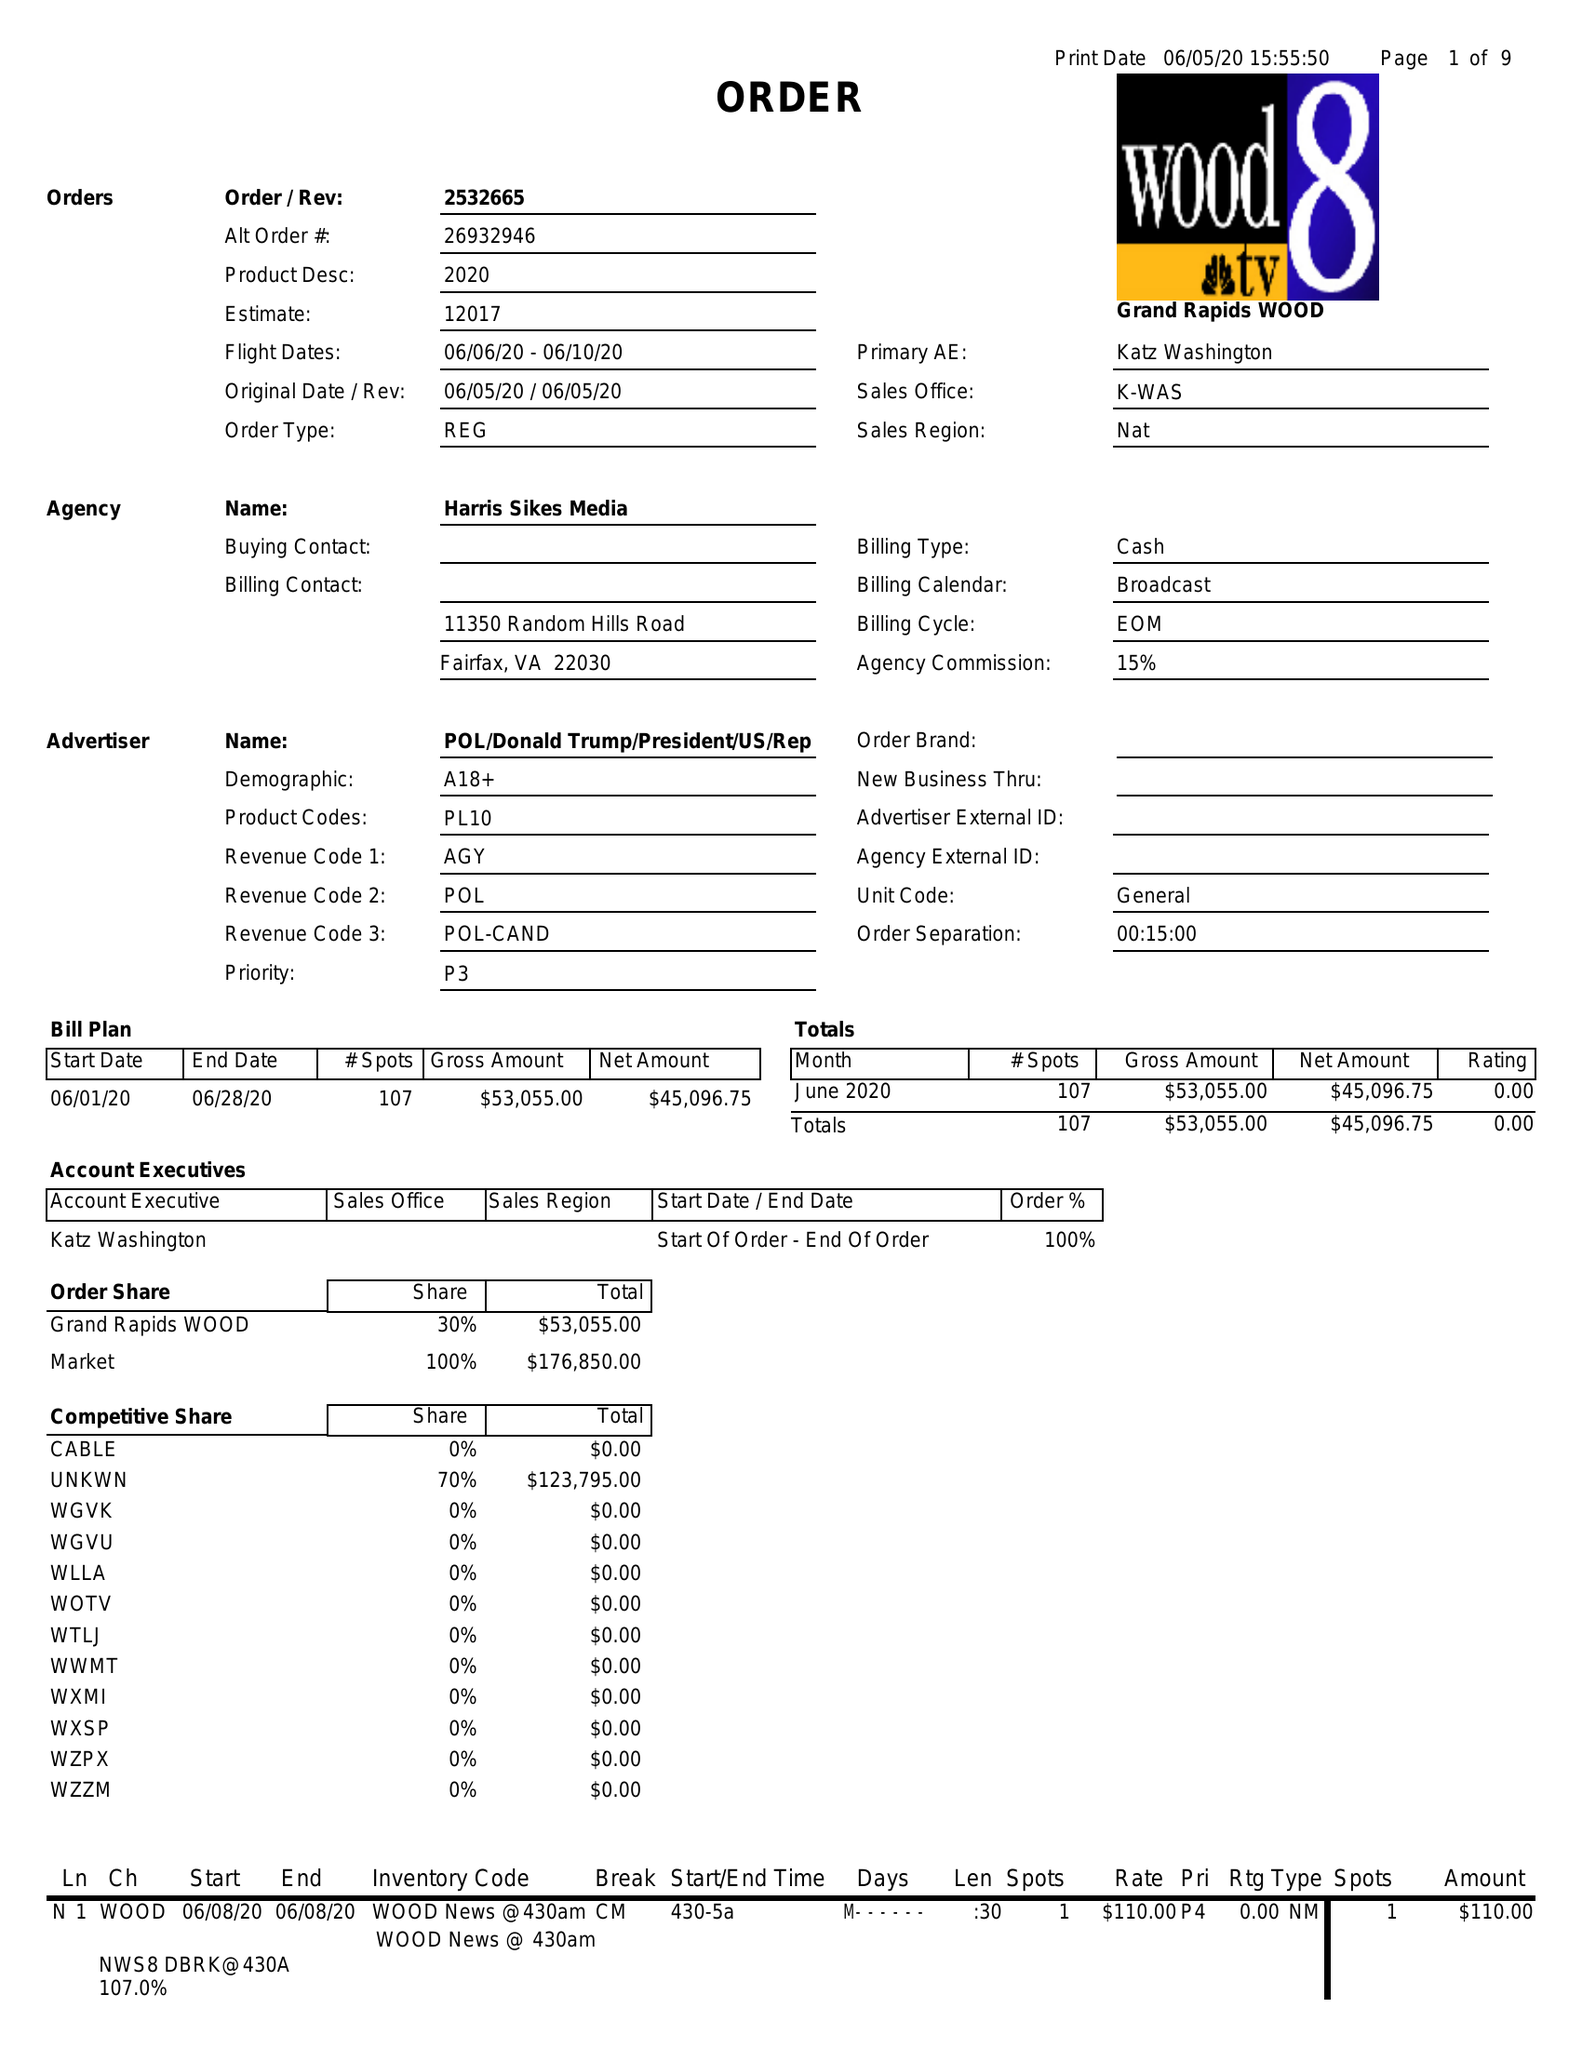What is the value for the flight_to?
Answer the question using a single word or phrase. 06/10/20 